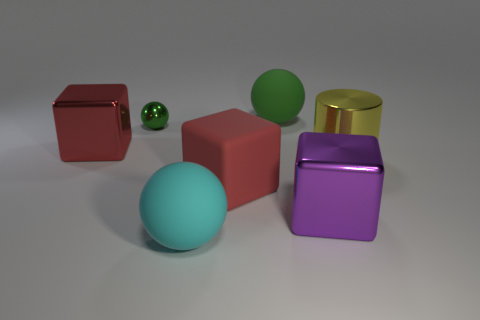Subtract all red blocks. How many were subtracted if there are1red blocks left? 1 Add 3 purple metal balls. How many objects exist? 10 Subtract all large purple metallic cubes. How many cubes are left? 2 Subtract all cubes. How many objects are left? 4 Subtract 3 balls. How many balls are left? 0 Subtract all purple blocks. How many blocks are left? 2 Subtract all gray cylinders. Subtract all purple spheres. How many cylinders are left? 1 Subtract all purple cylinders. How many purple blocks are left? 1 Subtract all large red blocks. Subtract all metal things. How many objects are left? 1 Add 2 cyan rubber spheres. How many cyan rubber spheres are left? 3 